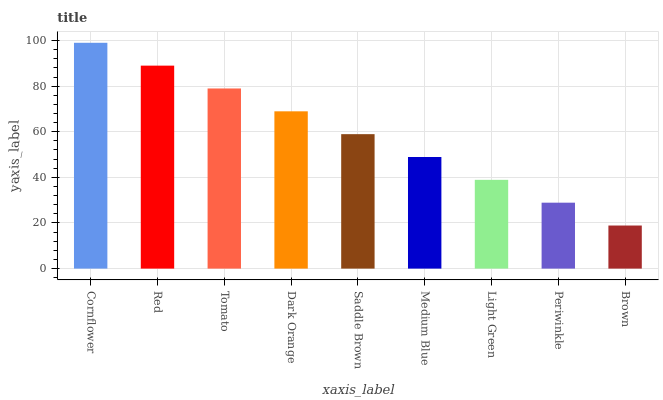Is Brown the minimum?
Answer yes or no. Yes. Is Cornflower the maximum?
Answer yes or no. Yes. Is Red the minimum?
Answer yes or no. No. Is Red the maximum?
Answer yes or no. No. Is Cornflower greater than Red?
Answer yes or no. Yes. Is Red less than Cornflower?
Answer yes or no. Yes. Is Red greater than Cornflower?
Answer yes or no. No. Is Cornflower less than Red?
Answer yes or no. No. Is Saddle Brown the high median?
Answer yes or no. Yes. Is Saddle Brown the low median?
Answer yes or no. Yes. Is Light Green the high median?
Answer yes or no. No. Is Light Green the low median?
Answer yes or no. No. 